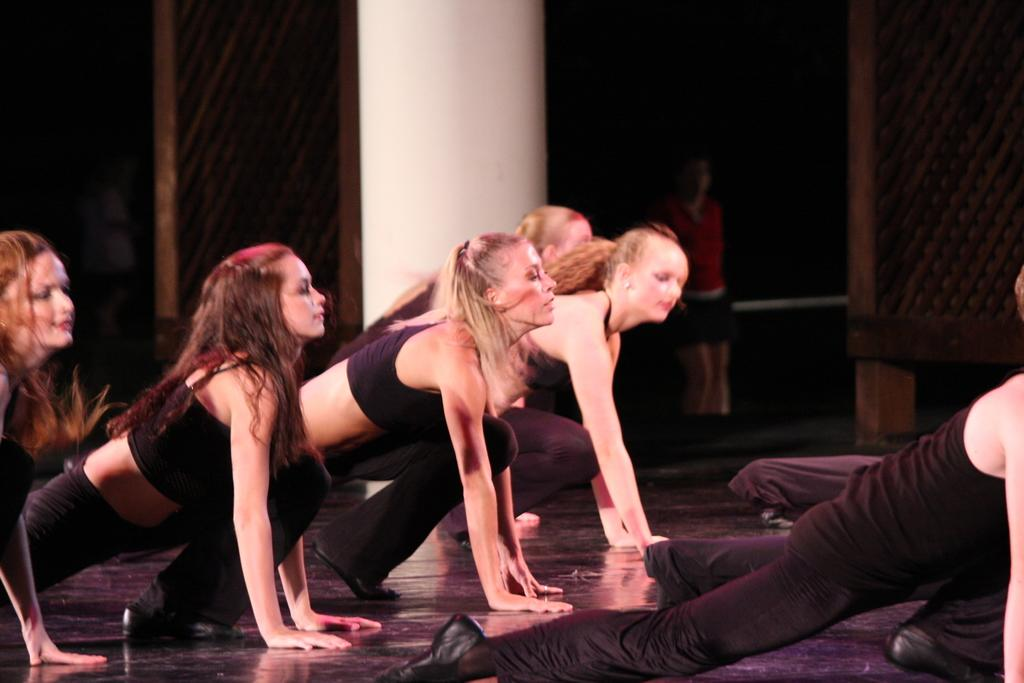What are the women in the image doing? The women in the image are doing exercise. Can you describe the setting of the image? There is a pillar in the image, which suggests it might be in a gym or exercise area. What type of paper is the farmer holding in the image? There is no farmer or paper present in the image; it features women doing exercise. 